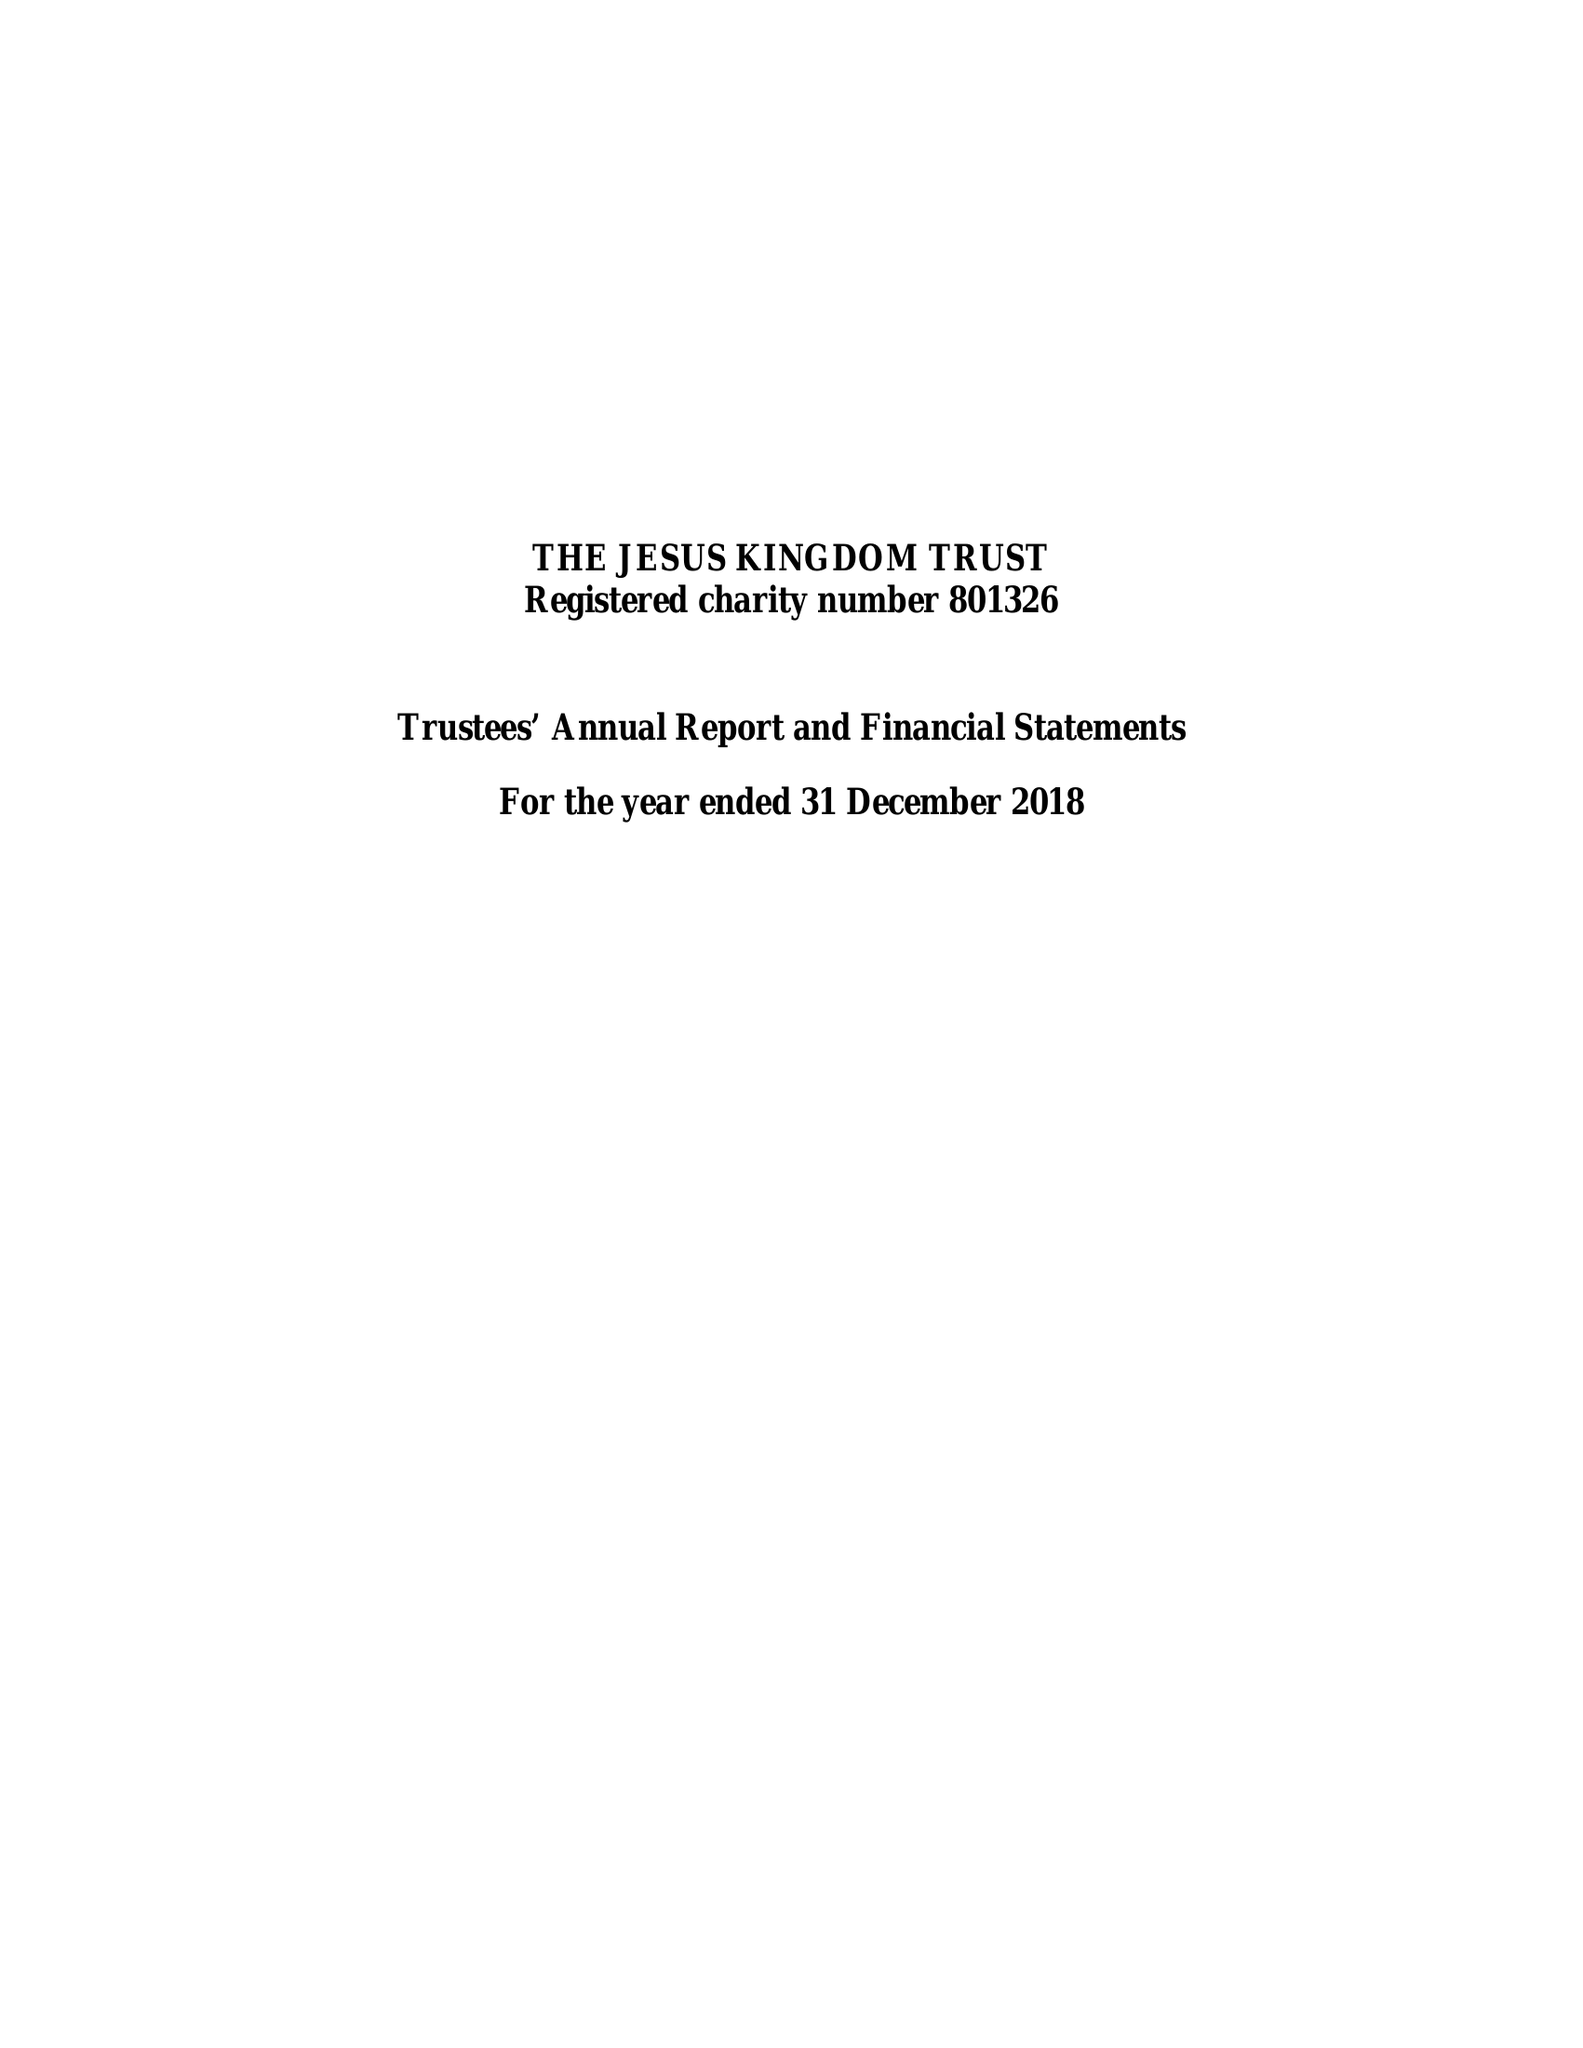What is the value for the charity_name?
Answer the question using a single word or phrase. The Jesus Kingdom Trust 